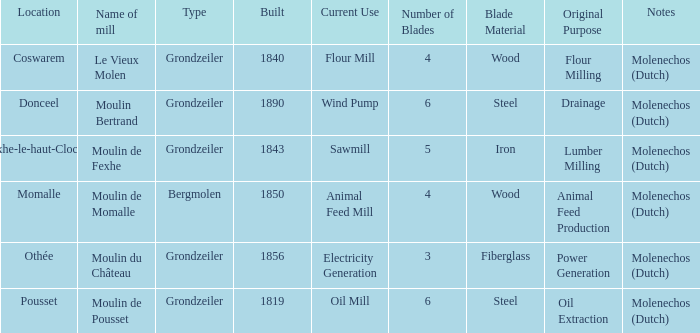What is the Location of the Moulin Bertrand Mill? Donceel. 